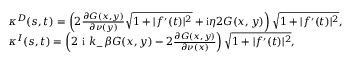Convert formula to latex. <formula><loc_0><loc_0><loc_500><loc_500>\begin{array} { r l } & { \kappa ^ { D } ( s , t ) = \left ( 2 \frac { \partial G ( x , y ) } { \partial \nu ( y ) } \sqrt { 1 + | f ^ { \prime } ( t ) | ^ { 2 } } + i \eta 2 G ( x , y ) \right ) \sqrt { 1 + | f ^ { \prime } ( t ) | ^ { 2 } } , } \\ & { \kappa ^ { I } ( s , t ) = \left ( 2 i k _ { - } \beta G ( x , y ) - 2 \frac { \partial G ( x , y ) } { \partial \nu ( x ) } \right ) \sqrt { 1 + | f ^ { \prime } ( t ) | ^ { 2 } } , } \end{array}</formula> 